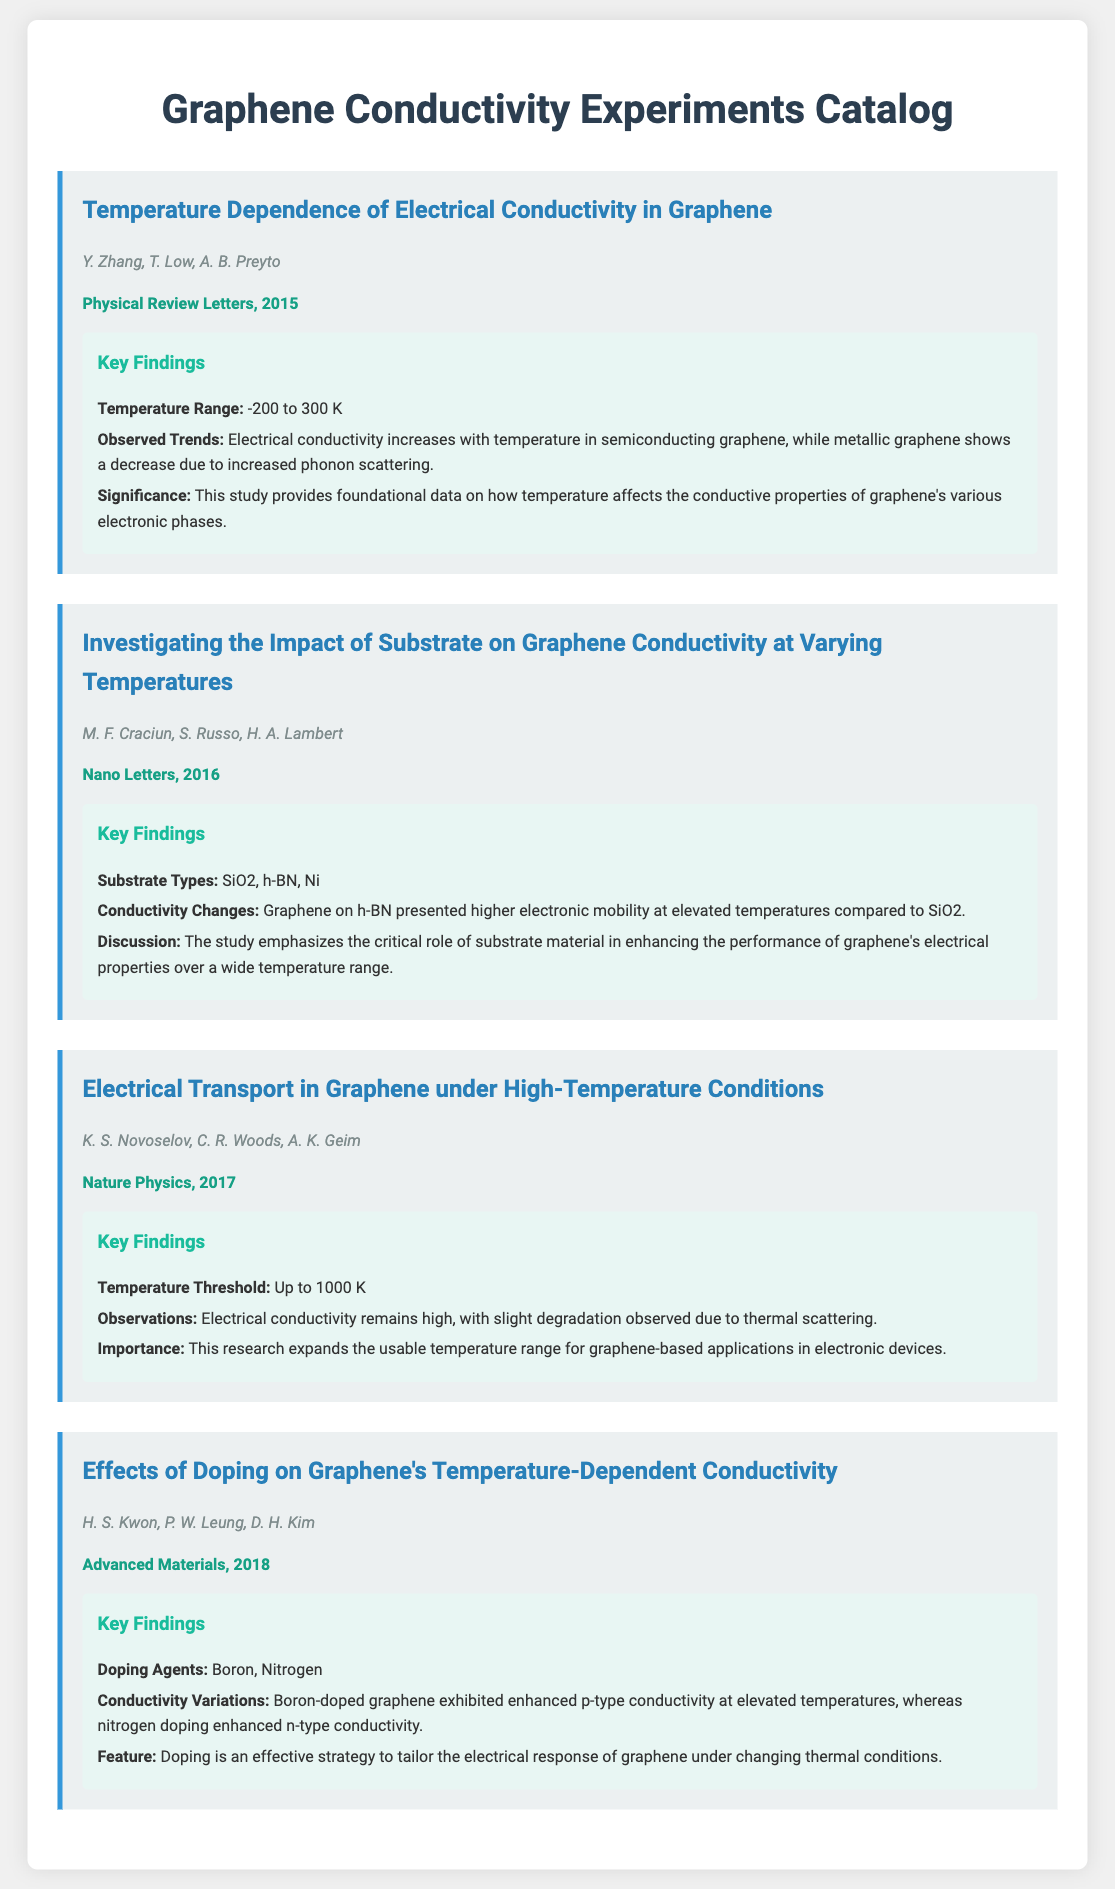What is the temperature range studied in the first experiment? The temperature range is highlighted in the key findings of the first experiment.
Answer: -200 to 300 K Who were the authors of the experiment published in 2016? The authors' names are provided in the experiment's details from 2016.
Answer: M. F. Craciun, S. Russo, H. A. Lambert What is the key substrate that showed higher electronic mobility? This information is specified in the key findings regarding substrates affecting conductivity.
Answer: h-BN What is the maximum temperature threshold studied in the third experiment? The maximum temperature threshold is given in the observations of the third experiment's key findings.
Answer: Up to 1000 K Which doping agent enhances n-type conductivity? The key findings discuss the effects of different doping agents on conductivity.
Answer: Nitrogen What phenomenon causes decreased electrical conductivity in metallic graphene? This detail is found in the observed trends of the first experiment's key findings.
Answer: Increased phonon scattering In which journal was the 2018 experiment published? The journal name is listed in the citation of the 2018 experiment.
Answer: Advanced Materials What main feature is highlighted regarding doping in the fourth experiment? The key findings discuss the importance of doping in enhancing conductivity.
Answer: Effective strategy to tailor electrical response 